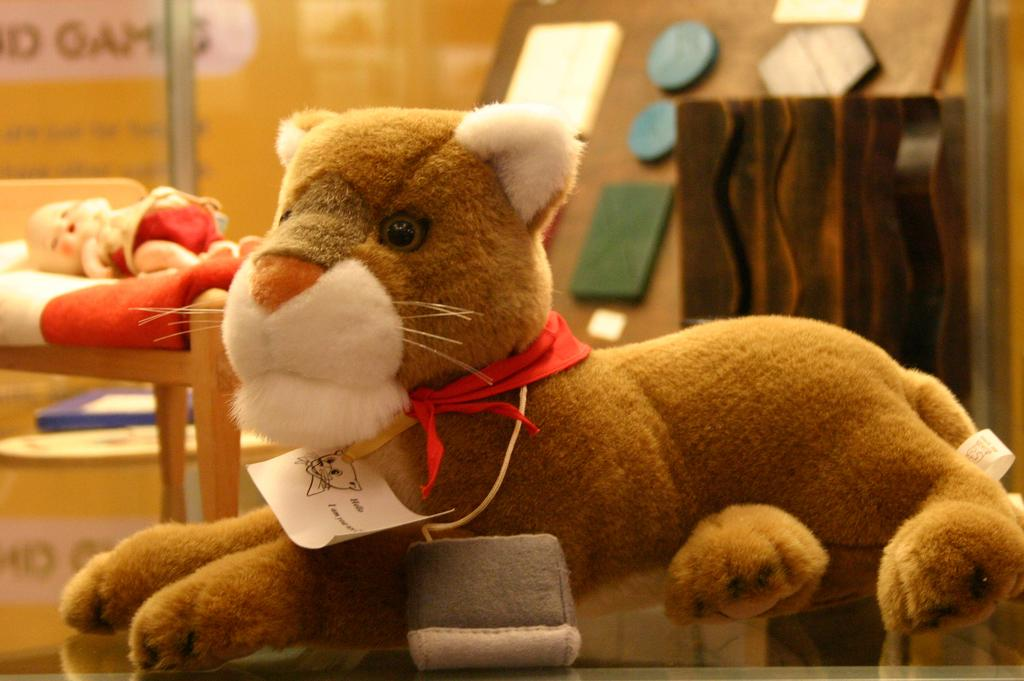What type of objects can be seen in the image? There are toys in the image. Can you describe any specific details about the toys? Unfortunately, the provided facts do not specify any details about the toys. Are there any other objects visible in the image besides the toys? Yes, there is a tag and other unspecified objects in the image. Where is the nearest playground to the location of the image? The provided facts do not give any information about the location of the image, so it is impossible to determine the nearest playground. How many beads are present in the image? There is no mention of beads in the provided facts, so it is impossible to determine their presence or quantity in the image. 